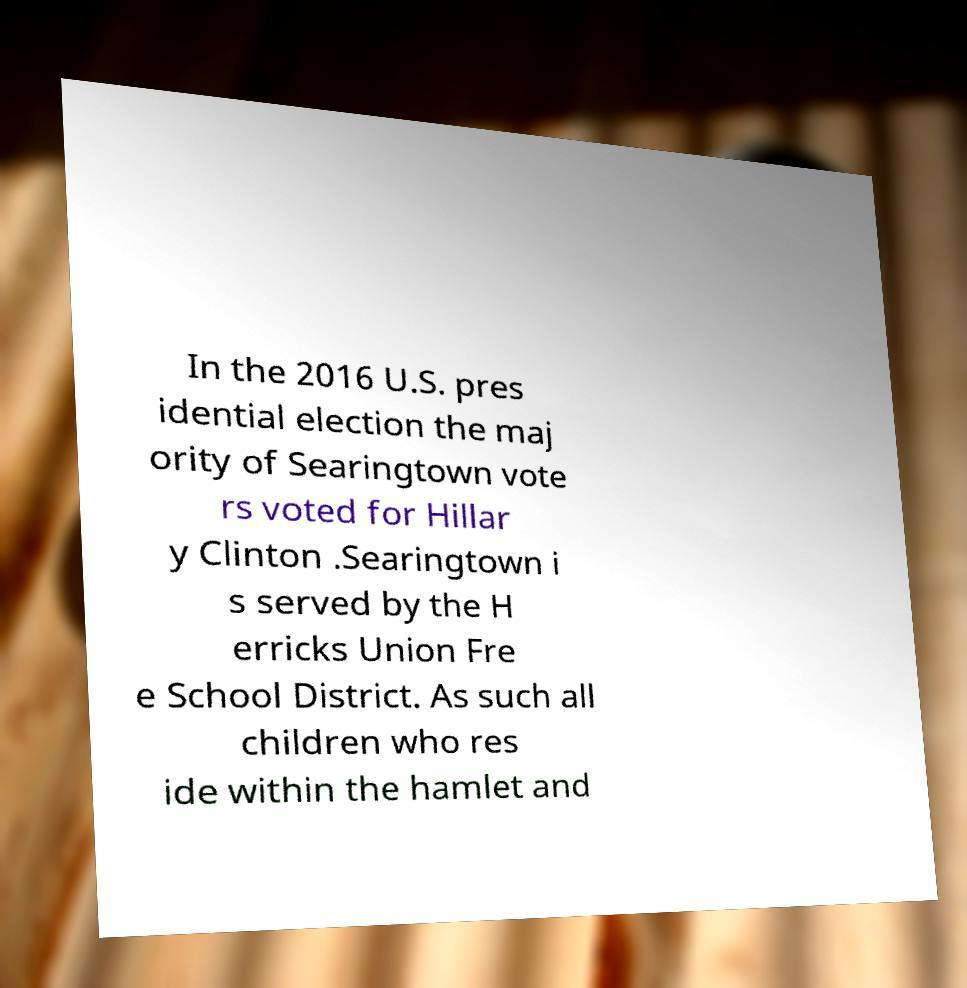Can you accurately transcribe the text from the provided image for me? In the 2016 U.S. pres idential election the maj ority of Searingtown vote rs voted for Hillar y Clinton .Searingtown i s served by the H erricks Union Fre e School District. As such all children who res ide within the hamlet and 